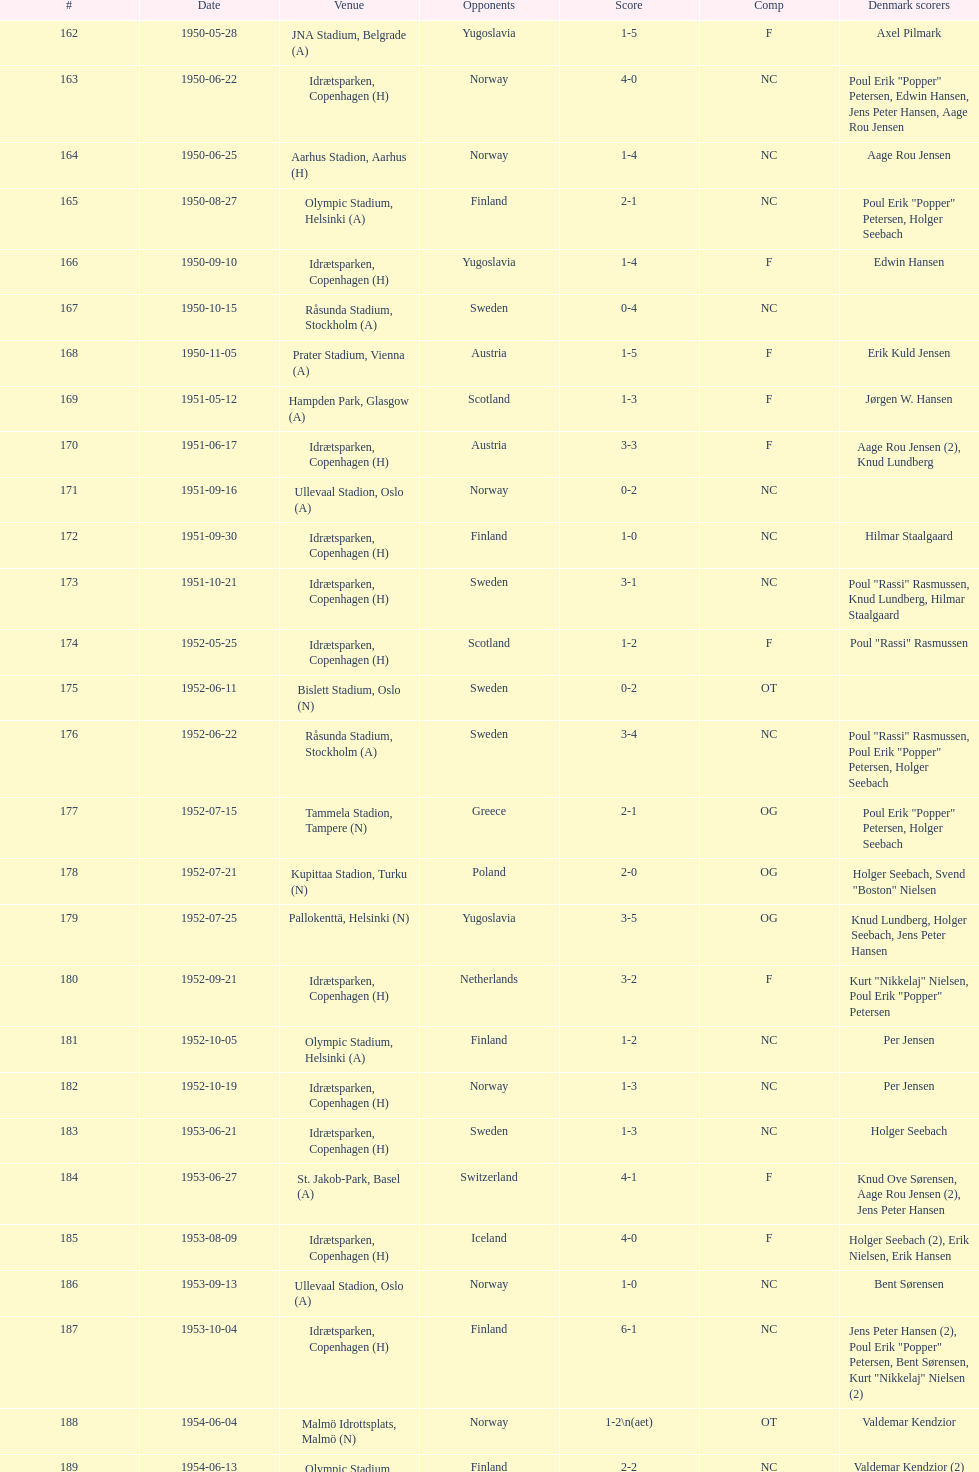What was the difference in score between the two teams in the last game? 1. 